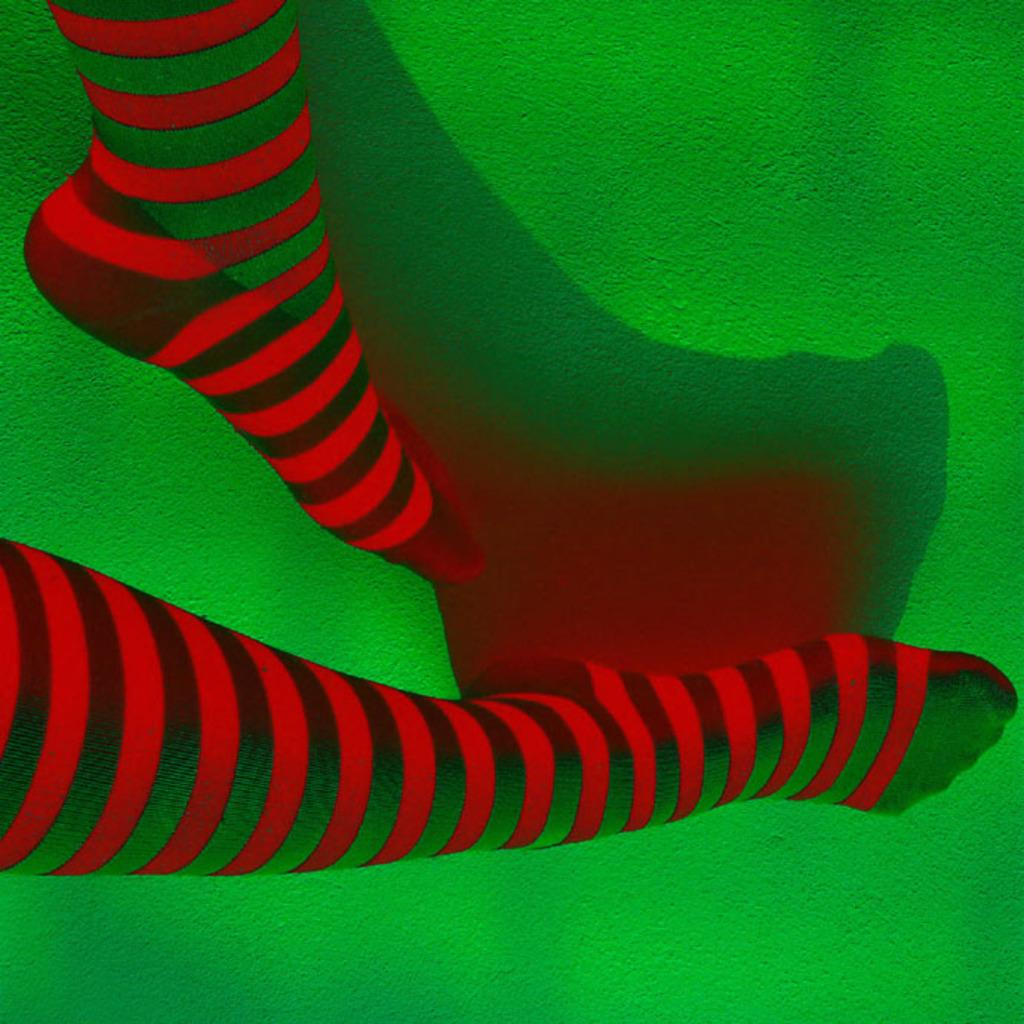What body part is visible in the image? There is a person's legs in the image. What colors are the person's legs? The person's legs are red and green in color. What color is the surface the legs are on? The legs are on a green colored surface. What other red object can be seen in the image? There is a red colored shade in the image. How many babies are visible in the image? There are no babies present in the image; it only shows a person's legs. What type of paper is being used to write on in the image? There is no paper or writing activity present in the image. 